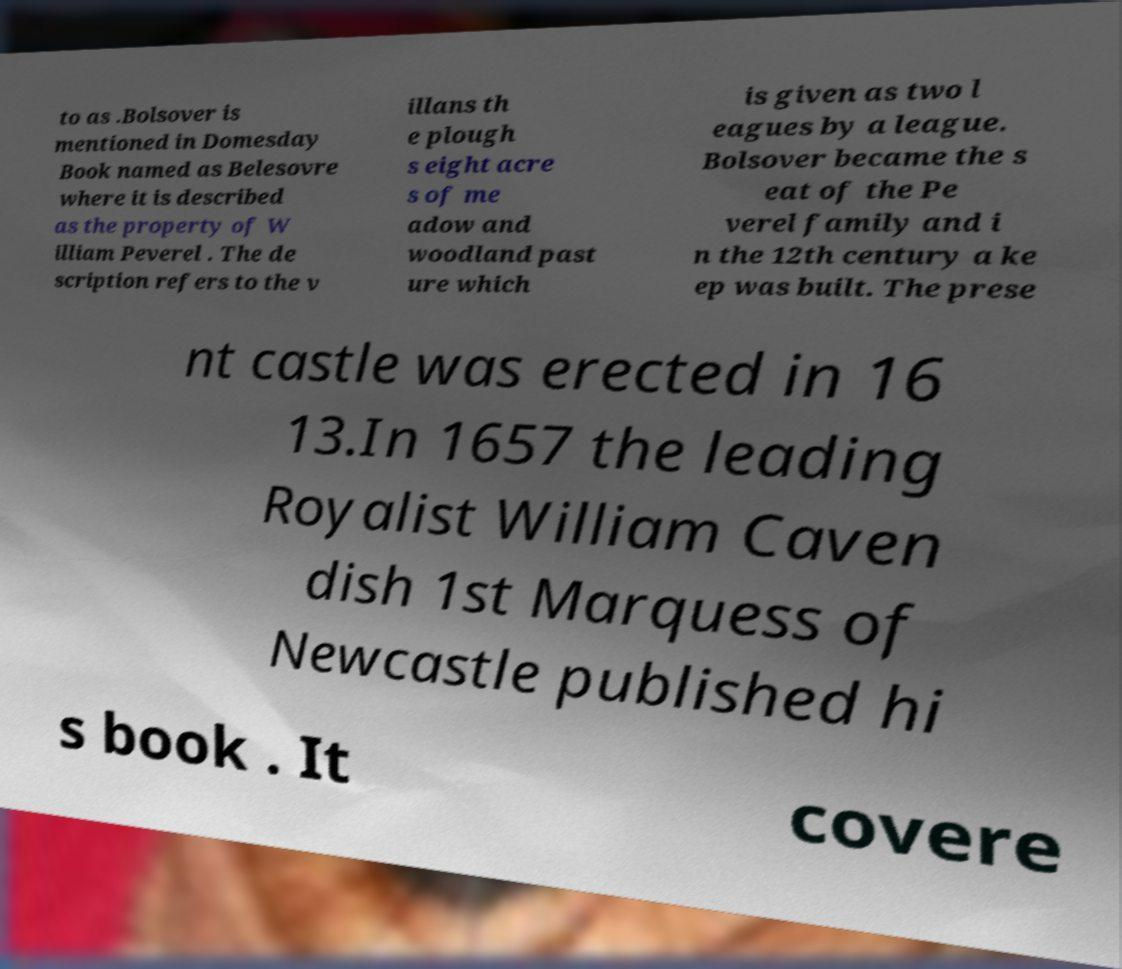Please read and relay the text visible in this image. What does it say? to as .Bolsover is mentioned in Domesday Book named as Belesovre where it is described as the property of W illiam Peverel . The de scription refers to the v illans th e plough s eight acre s of me adow and woodland past ure which is given as two l eagues by a league. Bolsover became the s eat of the Pe verel family and i n the 12th century a ke ep was built. The prese nt castle was erected in 16 13.In 1657 the leading Royalist William Caven dish 1st Marquess of Newcastle published hi s book . It covere 